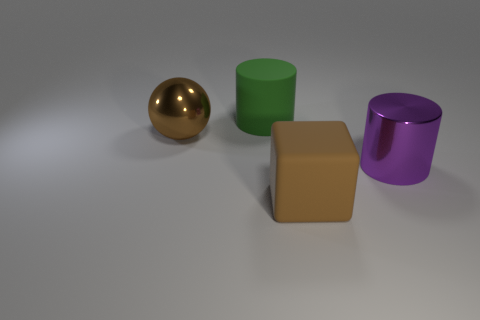Add 2 cylinders. How many objects exist? 6 Subtract all cubes. How many objects are left? 3 Add 1 red shiny things. How many red shiny things exist? 1 Subtract 0 gray cylinders. How many objects are left? 4 Subtract all red blocks. Subtract all yellow spheres. How many blocks are left? 1 Subtract all red cylinders. How many cyan blocks are left? 0 Subtract all green matte objects. Subtract all large yellow metallic balls. How many objects are left? 3 Add 2 big cylinders. How many big cylinders are left? 4 